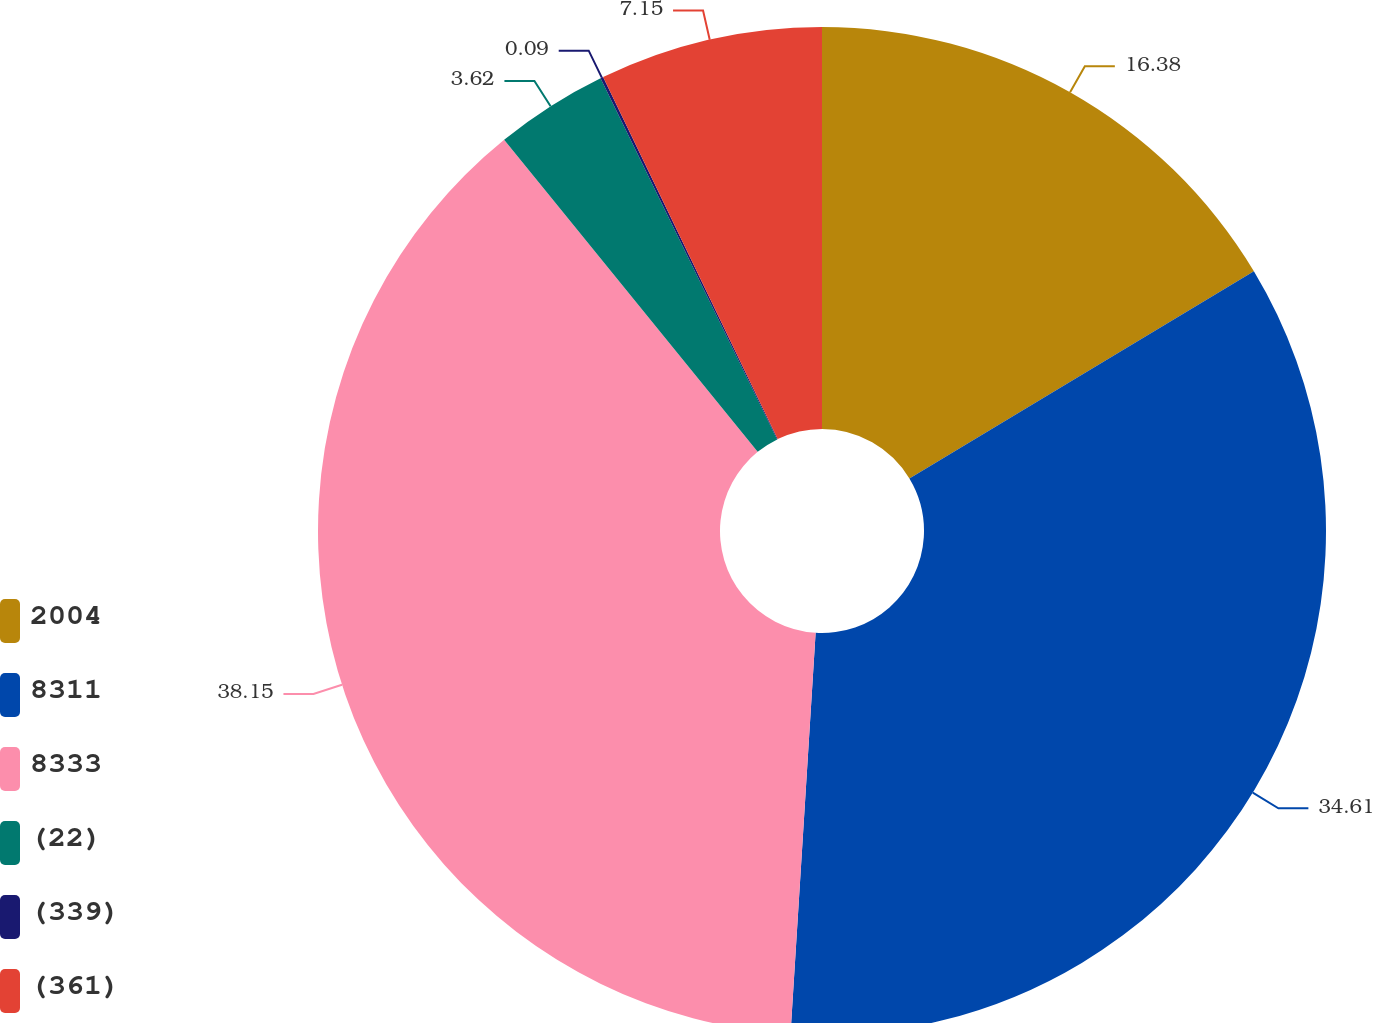Convert chart. <chart><loc_0><loc_0><loc_500><loc_500><pie_chart><fcel>2004<fcel>8311<fcel>8333<fcel>(22)<fcel>(339)<fcel>(361)<nl><fcel>16.38%<fcel>34.61%<fcel>38.14%<fcel>3.62%<fcel>0.09%<fcel>7.15%<nl></chart> 